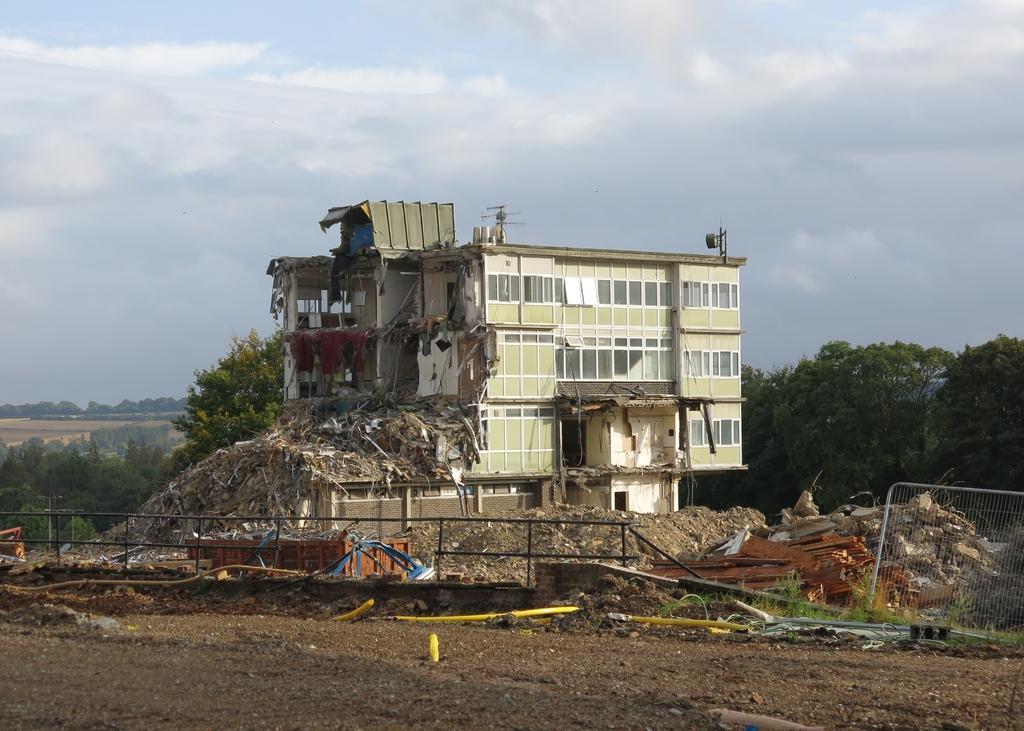Describe this image in one or two sentences. In the image there is fencing. Behind the fencing there are some other things. And there is a collapsed building. In the background there are trees. And also there is sky. 